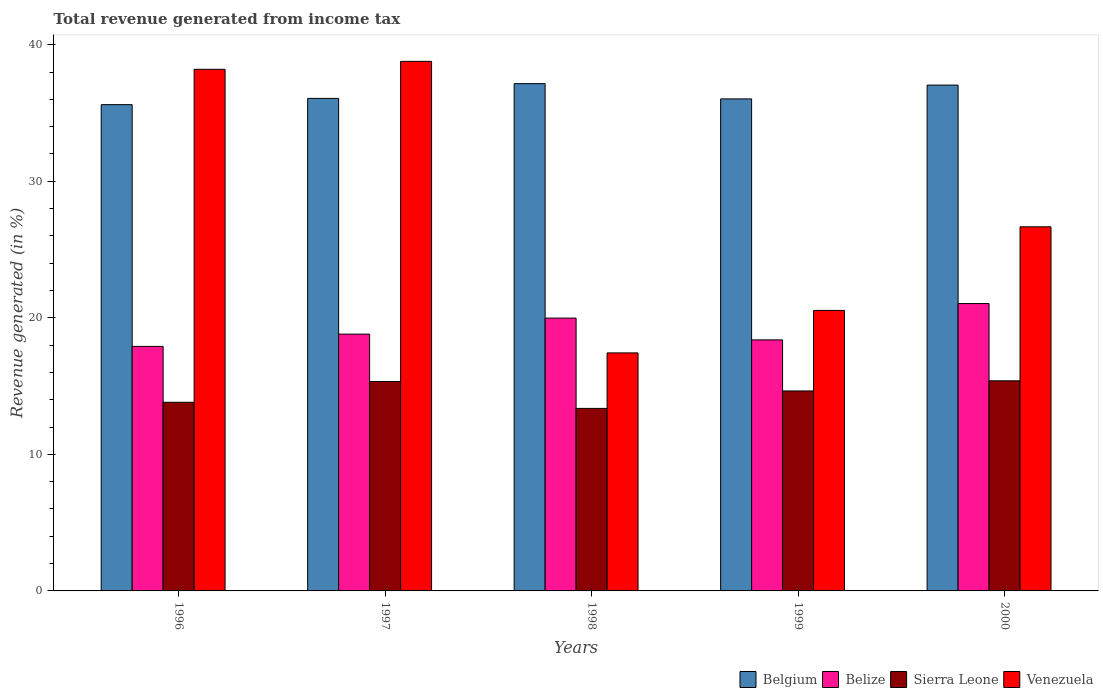Are the number of bars per tick equal to the number of legend labels?
Your response must be concise. Yes. Are the number of bars on each tick of the X-axis equal?
Provide a succinct answer. Yes. How many bars are there on the 2nd tick from the left?
Keep it short and to the point. 4. How many bars are there on the 4th tick from the right?
Offer a very short reply. 4. In how many cases, is the number of bars for a given year not equal to the number of legend labels?
Make the answer very short. 0. What is the total revenue generated in Venezuela in 1996?
Provide a succinct answer. 38.2. Across all years, what is the maximum total revenue generated in Belgium?
Offer a very short reply. 37.15. Across all years, what is the minimum total revenue generated in Sierra Leone?
Provide a succinct answer. 13.37. In which year was the total revenue generated in Belize maximum?
Provide a short and direct response. 2000. In which year was the total revenue generated in Belgium minimum?
Keep it short and to the point. 1996. What is the total total revenue generated in Venezuela in the graph?
Offer a very short reply. 141.62. What is the difference between the total revenue generated in Sierra Leone in 1997 and that in 1999?
Provide a short and direct response. 0.69. What is the difference between the total revenue generated in Belgium in 1999 and the total revenue generated in Sierra Leone in 1996?
Make the answer very short. 22.22. What is the average total revenue generated in Belize per year?
Offer a terse response. 19.22. In the year 1996, what is the difference between the total revenue generated in Belgium and total revenue generated in Sierra Leone?
Keep it short and to the point. 21.8. In how many years, is the total revenue generated in Belize greater than 12 %?
Offer a terse response. 5. What is the ratio of the total revenue generated in Venezuela in 1997 to that in 1999?
Your response must be concise. 1.89. What is the difference between the highest and the second highest total revenue generated in Venezuela?
Your answer should be compact. 0.58. What is the difference between the highest and the lowest total revenue generated in Sierra Leone?
Offer a terse response. 2.02. Is the sum of the total revenue generated in Venezuela in 1997 and 2000 greater than the maximum total revenue generated in Belize across all years?
Your answer should be compact. Yes. What does the 3rd bar from the left in 1997 represents?
Keep it short and to the point. Sierra Leone. What does the 4th bar from the right in 1996 represents?
Provide a short and direct response. Belgium. Are all the bars in the graph horizontal?
Provide a short and direct response. No. How many years are there in the graph?
Offer a terse response. 5. What is the difference between two consecutive major ticks on the Y-axis?
Keep it short and to the point. 10. Are the values on the major ticks of Y-axis written in scientific E-notation?
Offer a very short reply. No. Does the graph contain grids?
Provide a succinct answer. No. How many legend labels are there?
Offer a very short reply. 4. How are the legend labels stacked?
Provide a short and direct response. Horizontal. What is the title of the graph?
Make the answer very short. Total revenue generated from income tax. Does "Turks and Caicos Islands" appear as one of the legend labels in the graph?
Give a very brief answer. No. What is the label or title of the X-axis?
Offer a terse response. Years. What is the label or title of the Y-axis?
Ensure brevity in your answer.  Revenue generated (in %). What is the Revenue generated (in %) in Belgium in 1996?
Your answer should be compact. 35.61. What is the Revenue generated (in %) in Belize in 1996?
Give a very brief answer. 17.91. What is the Revenue generated (in %) in Sierra Leone in 1996?
Offer a very short reply. 13.81. What is the Revenue generated (in %) of Venezuela in 1996?
Your response must be concise. 38.2. What is the Revenue generated (in %) in Belgium in 1997?
Ensure brevity in your answer.  36.07. What is the Revenue generated (in %) in Belize in 1997?
Ensure brevity in your answer.  18.81. What is the Revenue generated (in %) in Sierra Leone in 1997?
Make the answer very short. 15.34. What is the Revenue generated (in %) of Venezuela in 1997?
Offer a very short reply. 38.78. What is the Revenue generated (in %) in Belgium in 1998?
Give a very brief answer. 37.15. What is the Revenue generated (in %) of Belize in 1998?
Give a very brief answer. 19.98. What is the Revenue generated (in %) in Sierra Leone in 1998?
Your answer should be very brief. 13.37. What is the Revenue generated (in %) in Venezuela in 1998?
Your response must be concise. 17.43. What is the Revenue generated (in %) of Belgium in 1999?
Provide a short and direct response. 36.03. What is the Revenue generated (in %) of Belize in 1999?
Offer a very short reply. 18.38. What is the Revenue generated (in %) of Sierra Leone in 1999?
Keep it short and to the point. 14.65. What is the Revenue generated (in %) of Venezuela in 1999?
Ensure brevity in your answer.  20.54. What is the Revenue generated (in %) in Belgium in 2000?
Offer a terse response. 37.05. What is the Revenue generated (in %) in Belize in 2000?
Provide a short and direct response. 21.05. What is the Revenue generated (in %) in Sierra Leone in 2000?
Offer a terse response. 15.39. What is the Revenue generated (in %) in Venezuela in 2000?
Your response must be concise. 26.67. Across all years, what is the maximum Revenue generated (in %) of Belgium?
Give a very brief answer. 37.15. Across all years, what is the maximum Revenue generated (in %) in Belize?
Your answer should be compact. 21.05. Across all years, what is the maximum Revenue generated (in %) of Sierra Leone?
Ensure brevity in your answer.  15.39. Across all years, what is the maximum Revenue generated (in %) in Venezuela?
Give a very brief answer. 38.78. Across all years, what is the minimum Revenue generated (in %) of Belgium?
Keep it short and to the point. 35.61. Across all years, what is the minimum Revenue generated (in %) in Belize?
Your response must be concise. 17.91. Across all years, what is the minimum Revenue generated (in %) of Sierra Leone?
Your answer should be very brief. 13.37. Across all years, what is the minimum Revenue generated (in %) in Venezuela?
Keep it short and to the point. 17.43. What is the total Revenue generated (in %) of Belgium in the graph?
Keep it short and to the point. 181.91. What is the total Revenue generated (in %) of Belize in the graph?
Give a very brief answer. 96.12. What is the total Revenue generated (in %) in Sierra Leone in the graph?
Keep it short and to the point. 72.55. What is the total Revenue generated (in %) of Venezuela in the graph?
Provide a succinct answer. 141.62. What is the difference between the Revenue generated (in %) in Belgium in 1996 and that in 1997?
Offer a very short reply. -0.46. What is the difference between the Revenue generated (in %) of Belize in 1996 and that in 1997?
Offer a terse response. -0.9. What is the difference between the Revenue generated (in %) of Sierra Leone in 1996 and that in 1997?
Your response must be concise. -1.52. What is the difference between the Revenue generated (in %) in Venezuela in 1996 and that in 1997?
Your answer should be very brief. -0.58. What is the difference between the Revenue generated (in %) of Belgium in 1996 and that in 1998?
Keep it short and to the point. -1.54. What is the difference between the Revenue generated (in %) of Belize in 1996 and that in 1998?
Make the answer very short. -2.07. What is the difference between the Revenue generated (in %) of Sierra Leone in 1996 and that in 1998?
Provide a short and direct response. 0.45. What is the difference between the Revenue generated (in %) of Venezuela in 1996 and that in 1998?
Ensure brevity in your answer.  20.77. What is the difference between the Revenue generated (in %) in Belgium in 1996 and that in 1999?
Make the answer very short. -0.42. What is the difference between the Revenue generated (in %) of Belize in 1996 and that in 1999?
Provide a succinct answer. -0.48. What is the difference between the Revenue generated (in %) in Sierra Leone in 1996 and that in 1999?
Provide a succinct answer. -0.83. What is the difference between the Revenue generated (in %) of Venezuela in 1996 and that in 1999?
Offer a very short reply. 17.66. What is the difference between the Revenue generated (in %) of Belgium in 1996 and that in 2000?
Make the answer very short. -1.43. What is the difference between the Revenue generated (in %) of Belize in 1996 and that in 2000?
Give a very brief answer. -3.14. What is the difference between the Revenue generated (in %) in Sierra Leone in 1996 and that in 2000?
Ensure brevity in your answer.  -1.57. What is the difference between the Revenue generated (in %) of Venezuela in 1996 and that in 2000?
Offer a terse response. 11.53. What is the difference between the Revenue generated (in %) in Belgium in 1997 and that in 1998?
Your answer should be compact. -1.08. What is the difference between the Revenue generated (in %) in Belize in 1997 and that in 1998?
Provide a short and direct response. -1.17. What is the difference between the Revenue generated (in %) in Sierra Leone in 1997 and that in 1998?
Ensure brevity in your answer.  1.97. What is the difference between the Revenue generated (in %) of Venezuela in 1997 and that in 1998?
Provide a succinct answer. 21.35. What is the difference between the Revenue generated (in %) of Belgium in 1997 and that in 1999?
Keep it short and to the point. 0.04. What is the difference between the Revenue generated (in %) in Belize in 1997 and that in 1999?
Ensure brevity in your answer.  0.42. What is the difference between the Revenue generated (in %) in Sierra Leone in 1997 and that in 1999?
Provide a succinct answer. 0.69. What is the difference between the Revenue generated (in %) in Venezuela in 1997 and that in 1999?
Offer a very short reply. 18.24. What is the difference between the Revenue generated (in %) of Belgium in 1997 and that in 2000?
Give a very brief answer. -0.98. What is the difference between the Revenue generated (in %) of Belize in 1997 and that in 2000?
Provide a short and direct response. -2.24. What is the difference between the Revenue generated (in %) in Sierra Leone in 1997 and that in 2000?
Make the answer very short. -0.05. What is the difference between the Revenue generated (in %) in Venezuela in 1997 and that in 2000?
Your answer should be very brief. 12.12. What is the difference between the Revenue generated (in %) in Belgium in 1998 and that in 1999?
Give a very brief answer. 1.12. What is the difference between the Revenue generated (in %) in Belize in 1998 and that in 1999?
Your response must be concise. 1.6. What is the difference between the Revenue generated (in %) in Sierra Leone in 1998 and that in 1999?
Your response must be concise. -1.28. What is the difference between the Revenue generated (in %) in Venezuela in 1998 and that in 1999?
Offer a very short reply. -3.11. What is the difference between the Revenue generated (in %) of Belgium in 1998 and that in 2000?
Ensure brevity in your answer.  0.1. What is the difference between the Revenue generated (in %) of Belize in 1998 and that in 2000?
Ensure brevity in your answer.  -1.07. What is the difference between the Revenue generated (in %) in Sierra Leone in 1998 and that in 2000?
Provide a succinct answer. -2.02. What is the difference between the Revenue generated (in %) of Venezuela in 1998 and that in 2000?
Keep it short and to the point. -9.24. What is the difference between the Revenue generated (in %) of Belgium in 1999 and that in 2000?
Keep it short and to the point. -1.01. What is the difference between the Revenue generated (in %) in Belize in 1999 and that in 2000?
Your answer should be very brief. -2.66. What is the difference between the Revenue generated (in %) of Sierra Leone in 1999 and that in 2000?
Ensure brevity in your answer.  -0.74. What is the difference between the Revenue generated (in %) of Venezuela in 1999 and that in 2000?
Your response must be concise. -6.12. What is the difference between the Revenue generated (in %) in Belgium in 1996 and the Revenue generated (in %) in Belize in 1997?
Offer a terse response. 16.81. What is the difference between the Revenue generated (in %) of Belgium in 1996 and the Revenue generated (in %) of Sierra Leone in 1997?
Your response must be concise. 20.28. What is the difference between the Revenue generated (in %) of Belgium in 1996 and the Revenue generated (in %) of Venezuela in 1997?
Offer a very short reply. -3.17. What is the difference between the Revenue generated (in %) in Belize in 1996 and the Revenue generated (in %) in Sierra Leone in 1997?
Offer a very short reply. 2.57. What is the difference between the Revenue generated (in %) in Belize in 1996 and the Revenue generated (in %) in Venezuela in 1997?
Your answer should be compact. -20.88. What is the difference between the Revenue generated (in %) of Sierra Leone in 1996 and the Revenue generated (in %) of Venezuela in 1997?
Provide a short and direct response. -24.97. What is the difference between the Revenue generated (in %) in Belgium in 1996 and the Revenue generated (in %) in Belize in 1998?
Your answer should be compact. 15.63. What is the difference between the Revenue generated (in %) in Belgium in 1996 and the Revenue generated (in %) in Sierra Leone in 1998?
Give a very brief answer. 22.25. What is the difference between the Revenue generated (in %) in Belgium in 1996 and the Revenue generated (in %) in Venezuela in 1998?
Give a very brief answer. 18.18. What is the difference between the Revenue generated (in %) of Belize in 1996 and the Revenue generated (in %) of Sierra Leone in 1998?
Ensure brevity in your answer.  4.54. What is the difference between the Revenue generated (in %) of Belize in 1996 and the Revenue generated (in %) of Venezuela in 1998?
Offer a terse response. 0.48. What is the difference between the Revenue generated (in %) of Sierra Leone in 1996 and the Revenue generated (in %) of Venezuela in 1998?
Your answer should be very brief. -3.62. What is the difference between the Revenue generated (in %) in Belgium in 1996 and the Revenue generated (in %) in Belize in 1999?
Your answer should be very brief. 17.23. What is the difference between the Revenue generated (in %) in Belgium in 1996 and the Revenue generated (in %) in Sierra Leone in 1999?
Your answer should be very brief. 20.97. What is the difference between the Revenue generated (in %) of Belgium in 1996 and the Revenue generated (in %) of Venezuela in 1999?
Your answer should be very brief. 15.07. What is the difference between the Revenue generated (in %) of Belize in 1996 and the Revenue generated (in %) of Sierra Leone in 1999?
Provide a short and direct response. 3.26. What is the difference between the Revenue generated (in %) in Belize in 1996 and the Revenue generated (in %) in Venezuela in 1999?
Your response must be concise. -2.63. What is the difference between the Revenue generated (in %) of Sierra Leone in 1996 and the Revenue generated (in %) of Venezuela in 1999?
Provide a succinct answer. -6.73. What is the difference between the Revenue generated (in %) in Belgium in 1996 and the Revenue generated (in %) in Belize in 2000?
Give a very brief answer. 14.57. What is the difference between the Revenue generated (in %) in Belgium in 1996 and the Revenue generated (in %) in Sierra Leone in 2000?
Your answer should be compact. 20.23. What is the difference between the Revenue generated (in %) in Belgium in 1996 and the Revenue generated (in %) in Venezuela in 2000?
Your response must be concise. 8.95. What is the difference between the Revenue generated (in %) in Belize in 1996 and the Revenue generated (in %) in Sierra Leone in 2000?
Your answer should be very brief. 2.52. What is the difference between the Revenue generated (in %) in Belize in 1996 and the Revenue generated (in %) in Venezuela in 2000?
Provide a short and direct response. -8.76. What is the difference between the Revenue generated (in %) of Sierra Leone in 1996 and the Revenue generated (in %) of Venezuela in 2000?
Your response must be concise. -12.85. What is the difference between the Revenue generated (in %) of Belgium in 1997 and the Revenue generated (in %) of Belize in 1998?
Give a very brief answer. 16.09. What is the difference between the Revenue generated (in %) of Belgium in 1997 and the Revenue generated (in %) of Sierra Leone in 1998?
Offer a terse response. 22.7. What is the difference between the Revenue generated (in %) of Belgium in 1997 and the Revenue generated (in %) of Venezuela in 1998?
Offer a very short reply. 18.64. What is the difference between the Revenue generated (in %) in Belize in 1997 and the Revenue generated (in %) in Sierra Leone in 1998?
Ensure brevity in your answer.  5.44. What is the difference between the Revenue generated (in %) in Belize in 1997 and the Revenue generated (in %) in Venezuela in 1998?
Offer a very short reply. 1.38. What is the difference between the Revenue generated (in %) of Sierra Leone in 1997 and the Revenue generated (in %) of Venezuela in 1998?
Provide a succinct answer. -2.1. What is the difference between the Revenue generated (in %) of Belgium in 1997 and the Revenue generated (in %) of Belize in 1999?
Your answer should be compact. 17.68. What is the difference between the Revenue generated (in %) of Belgium in 1997 and the Revenue generated (in %) of Sierra Leone in 1999?
Your response must be concise. 21.42. What is the difference between the Revenue generated (in %) of Belgium in 1997 and the Revenue generated (in %) of Venezuela in 1999?
Your response must be concise. 15.53. What is the difference between the Revenue generated (in %) in Belize in 1997 and the Revenue generated (in %) in Sierra Leone in 1999?
Your answer should be compact. 4.16. What is the difference between the Revenue generated (in %) of Belize in 1997 and the Revenue generated (in %) of Venezuela in 1999?
Make the answer very short. -1.74. What is the difference between the Revenue generated (in %) in Sierra Leone in 1997 and the Revenue generated (in %) in Venezuela in 1999?
Make the answer very short. -5.21. What is the difference between the Revenue generated (in %) in Belgium in 1997 and the Revenue generated (in %) in Belize in 2000?
Provide a short and direct response. 15.02. What is the difference between the Revenue generated (in %) of Belgium in 1997 and the Revenue generated (in %) of Sierra Leone in 2000?
Ensure brevity in your answer.  20.68. What is the difference between the Revenue generated (in %) of Belgium in 1997 and the Revenue generated (in %) of Venezuela in 2000?
Provide a short and direct response. 9.4. What is the difference between the Revenue generated (in %) of Belize in 1997 and the Revenue generated (in %) of Sierra Leone in 2000?
Offer a terse response. 3.42. What is the difference between the Revenue generated (in %) of Belize in 1997 and the Revenue generated (in %) of Venezuela in 2000?
Your answer should be very brief. -7.86. What is the difference between the Revenue generated (in %) of Sierra Leone in 1997 and the Revenue generated (in %) of Venezuela in 2000?
Your answer should be compact. -11.33. What is the difference between the Revenue generated (in %) of Belgium in 1998 and the Revenue generated (in %) of Belize in 1999?
Ensure brevity in your answer.  18.76. What is the difference between the Revenue generated (in %) of Belgium in 1998 and the Revenue generated (in %) of Sierra Leone in 1999?
Ensure brevity in your answer.  22.5. What is the difference between the Revenue generated (in %) in Belgium in 1998 and the Revenue generated (in %) in Venezuela in 1999?
Offer a terse response. 16.61. What is the difference between the Revenue generated (in %) in Belize in 1998 and the Revenue generated (in %) in Sierra Leone in 1999?
Your answer should be compact. 5.33. What is the difference between the Revenue generated (in %) in Belize in 1998 and the Revenue generated (in %) in Venezuela in 1999?
Keep it short and to the point. -0.56. What is the difference between the Revenue generated (in %) of Sierra Leone in 1998 and the Revenue generated (in %) of Venezuela in 1999?
Give a very brief answer. -7.17. What is the difference between the Revenue generated (in %) in Belgium in 1998 and the Revenue generated (in %) in Belize in 2000?
Offer a very short reply. 16.1. What is the difference between the Revenue generated (in %) of Belgium in 1998 and the Revenue generated (in %) of Sierra Leone in 2000?
Provide a succinct answer. 21.76. What is the difference between the Revenue generated (in %) of Belgium in 1998 and the Revenue generated (in %) of Venezuela in 2000?
Your response must be concise. 10.48. What is the difference between the Revenue generated (in %) of Belize in 1998 and the Revenue generated (in %) of Sierra Leone in 2000?
Ensure brevity in your answer.  4.59. What is the difference between the Revenue generated (in %) of Belize in 1998 and the Revenue generated (in %) of Venezuela in 2000?
Your answer should be very brief. -6.69. What is the difference between the Revenue generated (in %) of Sierra Leone in 1998 and the Revenue generated (in %) of Venezuela in 2000?
Provide a short and direct response. -13.3. What is the difference between the Revenue generated (in %) of Belgium in 1999 and the Revenue generated (in %) of Belize in 2000?
Your answer should be very brief. 14.99. What is the difference between the Revenue generated (in %) of Belgium in 1999 and the Revenue generated (in %) of Sierra Leone in 2000?
Offer a terse response. 20.65. What is the difference between the Revenue generated (in %) in Belgium in 1999 and the Revenue generated (in %) in Venezuela in 2000?
Give a very brief answer. 9.37. What is the difference between the Revenue generated (in %) of Belize in 1999 and the Revenue generated (in %) of Sierra Leone in 2000?
Your answer should be very brief. 3. What is the difference between the Revenue generated (in %) in Belize in 1999 and the Revenue generated (in %) in Venezuela in 2000?
Provide a short and direct response. -8.28. What is the difference between the Revenue generated (in %) of Sierra Leone in 1999 and the Revenue generated (in %) of Venezuela in 2000?
Offer a terse response. -12.02. What is the average Revenue generated (in %) of Belgium per year?
Your answer should be very brief. 36.38. What is the average Revenue generated (in %) of Belize per year?
Ensure brevity in your answer.  19.22. What is the average Revenue generated (in %) in Sierra Leone per year?
Ensure brevity in your answer.  14.51. What is the average Revenue generated (in %) in Venezuela per year?
Offer a terse response. 28.32. In the year 1996, what is the difference between the Revenue generated (in %) of Belgium and Revenue generated (in %) of Belize?
Give a very brief answer. 17.7. In the year 1996, what is the difference between the Revenue generated (in %) of Belgium and Revenue generated (in %) of Sierra Leone?
Your answer should be compact. 21.8. In the year 1996, what is the difference between the Revenue generated (in %) in Belgium and Revenue generated (in %) in Venezuela?
Give a very brief answer. -2.59. In the year 1996, what is the difference between the Revenue generated (in %) in Belize and Revenue generated (in %) in Sierra Leone?
Provide a succinct answer. 4.09. In the year 1996, what is the difference between the Revenue generated (in %) in Belize and Revenue generated (in %) in Venezuela?
Your answer should be compact. -20.29. In the year 1996, what is the difference between the Revenue generated (in %) of Sierra Leone and Revenue generated (in %) of Venezuela?
Your answer should be compact. -24.39. In the year 1997, what is the difference between the Revenue generated (in %) in Belgium and Revenue generated (in %) in Belize?
Offer a very short reply. 17.26. In the year 1997, what is the difference between the Revenue generated (in %) in Belgium and Revenue generated (in %) in Sierra Leone?
Give a very brief answer. 20.73. In the year 1997, what is the difference between the Revenue generated (in %) of Belgium and Revenue generated (in %) of Venezuela?
Keep it short and to the point. -2.71. In the year 1997, what is the difference between the Revenue generated (in %) in Belize and Revenue generated (in %) in Sierra Leone?
Provide a short and direct response. 3.47. In the year 1997, what is the difference between the Revenue generated (in %) in Belize and Revenue generated (in %) in Venezuela?
Give a very brief answer. -19.98. In the year 1997, what is the difference between the Revenue generated (in %) in Sierra Leone and Revenue generated (in %) in Venezuela?
Ensure brevity in your answer.  -23.45. In the year 1998, what is the difference between the Revenue generated (in %) in Belgium and Revenue generated (in %) in Belize?
Your answer should be compact. 17.17. In the year 1998, what is the difference between the Revenue generated (in %) in Belgium and Revenue generated (in %) in Sierra Leone?
Your answer should be compact. 23.78. In the year 1998, what is the difference between the Revenue generated (in %) of Belgium and Revenue generated (in %) of Venezuela?
Provide a succinct answer. 19.72. In the year 1998, what is the difference between the Revenue generated (in %) in Belize and Revenue generated (in %) in Sierra Leone?
Your answer should be very brief. 6.61. In the year 1998, what is the difference between the Revenue generated (in %) of Belize and Revenue generated (in %) of Venezuela?
Your answer should be compact. 2.55. In the year 1998, what is the difference between the Revenue generated (in %) of Sierra Leone and Revenue generated (in %) of Venezuela?
Keep it short and to the point. -4.06. In the year 1999, what is the difference between the Revenue generated (in %) in Belgium and Revenue generated (in %) in Belize?
Keep it short and to the point. 17.65. In the year 1999, what is the difference between the Revenue generated (in %) in Belgium and Revenue generated (in %) in Sierra Leone?
Make the answer very short. 21.39. In the year 1999, what is the difference between the Revenue generated (in %) of Belgium and Revenue generated (in %) of Venezuela?
Ensure brevity in your answer.  15.49. In the year 1999, what is the difference between the Revenue generated (in %) of Belize and Revenue generated (in %) of Sierra Leone?
Provide a short and direct response. 3.74. In the year 1999, what is the difference between the Revenue generated (in %) in Belize and Revenue generated (in %) in Venezuela?
Ensure brevity in your answer.  -2.16. In the year 1999, what is the difference between the Revenue generated (in %) in Sierra Leone and Revenue generated (in %) in Venezuela?
Make the answer very short. -5.9. In the year 2000, what is the difference between the Revenue generated (in %) in Belgium and Revenue generated (in %) in Belize?
Offer a terse response. 16. In the year 2000, what is the difference between the Revenue generated (in %) of Belgium and Revenue generated (in %) of Sierra Leone?
Give a very brief answer. 21.66. In the year 2000, what is the difference between the Revenue generated (in %) of Belgium and Revenue generated (in %) of Venezuela?
Give a very brief answer. 10.38. In the year 2000, what is the difference between the Revenue generated (in %) of Belize and Revenue generated (in %) of Sierra Leone?
Offer a terse response. 5.66. In the year 2000, what is the difference between the Revenue generated (in %) of Belize and Revenue generated (in %) of Venezuela?
Offer a very short reply. -5.62. In the year 2000, what is the difference between the Revenue generated (in %) of Sierra Leone and Revenue generated (in %) of Venezuela?
Offer a terse response. -11.28. What is the ratio of the Revenue generated (in %) in Belgium in 1996 to that in 1997?
Make the answer very short. 0.99. What is the ratio of the Revenue generated (in %) of Belize in 1996 to that in 1997?
Your answer should be very brief. 0.95. What is the ratio of the Revenue generated (in %) in Sierra Leone in 1996 to that in 1997?
Give a very brief answer. 0.9. What is the ratio of the Revenue generated (in %) in Belgium in 1996 to that in 1998?
Ensure brevity in your answer.  0.96. What is the ratio of the Revenue generated (in %) of Belize in 1996 to that in 1998?
Offer a terse response. 0.9. What is the ratio of the Revenue generated (in %) of Sierra Leone in 1996 to that in 1998?
Provide a succinct answer. 1.03. What is the ratio of the Revenue generated (in %) in Venezuela in 1996 to that in 1998?
Keep it short and to the point. 2.19. What is the ratio of the Revenue generated (in %) of Belgium in 1996 to that in 1999?
Your answer should be very brief. 0.99. What is the ratio of the Revenue generated (in %) of Belize in 1996 to that in 1999?
Your answer should be very brief. 0.97. What is the ratio of the Revenue generated (in %) in Sierra Leone in 1996 to that in 1999?
Your answer should be very brief. 0.94. What is the ratio of the Revenue generated (in %) of Venezuela in 1996 to that in 1999?
Your response must be concise. 1.86. What is the ratio of the Revenue generated (in %) of Belgium in 1996 to that in 2000?
Give a very brief answer. 0.96. What is the ratio of the Revenue generated (in %) in Belize in 1996 to that in 2000?
Your response must be concise. 0.85. What is the ratio of the Revenue generated (in %) in Sierra Leone in 1996 to that in 2000?
Make the answer very short. 0.9. What is the ratio of the Revenue generated (in %) of Venezuela in 1996 to that in 2000?
Ensure brevity in your answer.  1.43. What is the ratio of the Revenue generated (in %) in Belgium in 1997 to that in 1998?
Your response must be concise. 0.97. What is the ratio of the Revenue generated (in %) in Belize in 1997 to that in 1998?
Offer a terse response. 0.94. What is the ratio of the Revenue generated (in %) in Sierra Leone in 1997 to that in 1998?
Make the answer very short. 1.15. What is the ratio of the Revenue generated (in %) in Venezuela in 1997 to that in 1998?
Keep it short and to the point. 2.22. What is the ratio of the Revenue generated (in %) of Sierra Leone in 1997 to that in 1999?
Provide a short and direct response. 1.05. What is the ratio of the Revenue generated (in %) of Venezuela in 1997 to that in 1999?
Your answer should be very brief. 1.89. What is the ratio of the Revenue generated (in %) in Belgium in 1997 to that in 2000?
Give a very brief answer. 0.97. What is the ratio of the Revenue generated (in %) in Belize in 1997 to that in 2000?
Your response must be concise. 0.89. What is the ratio of the Revenue generated (in %) in Sierra Leone in 1997 to that in 2000?
Make the answer very short. 1. What is the ratio of the Revenue generated (in %) of Venezuela in 1997 to that in 2000?
Your answer should be compact. 1.45. What is the ratio of the Revenue generated (in %) of Belgium in 1998 to that in 1999?
Offer a terse response. 1.03. What is the ratio of the Revenue generated (in %) in Belize in 1998 to that in 1999?
Keep it short and to the point. 1.09. What is the ratio of the Revenue generated (in %) in Sierra Leone in 1998 to that in 1999?
Ensure brevity in your answer.  0.91. What is the ratio of the Revenue generated (in %) of Venezuela in 1998 to that in 1999?
Offer a very short reply. 0.85. What is the ratio of the Revenue generated (in %) of Belize in 1998 to that in 2000?
Offer a very short reply. 0.95. What is the ratio of the Revenue generated (in %) in Sierra Leone in 1998 to that in 2000?
Make the answer very short. 0.87. What is the ratio of the Revenue generated (in %) in Venezuela in 1998 to that in 2000?
Make the answer very short. 0.65. What is the ratio of the Revenue generated (in %) of Belgium in 1999 to that in 2000?
Make the answer very short. 0.97. What is the ratio of the Revenue generated (in %) in Belize in 1999 to that in 2000?
Your response must be concise. 0.87. What is the ratio of the Revenue generated (in %) of Sierra Leone in 1999 to that in 2000?
Keep it short and to the point. 0.95. What is the ratio of the Revenue generated (in %) in Venezuela in 1999 to that in 2000?
Offer a very short reply. 0.77. What is the difference between the highest and the second highest Revenue generated (in %) in Belgium?
Offer a terse response. 0.1. What is the difference between the highest and the second highest Revenue generated (in %) in Belize?
Give a very brief answer. 1.07. What is the difference between the highest and the second highest Revenue generated (in %) in Sierra Leone?
Offer a very short reply. 0.05. What is the difference between the highest and the second highest Revenue generated (in %) of Venezuela?
Provide a succinct answer. 0.58. What is the difference between the highest and the lowest Revenue generated (in %) of Belgium?
Your answer should be very brief. 1.54. What is the difference between the highest and the lowest Revenue generated (in %) of Belize?
Your answer should be very brief. 3.14. What is the difference between the highest and the lowest Revenue generated (in %) of Sierra Leone?
Your answer should be very brief. 2.02. What is the difference between the highest and the lowest Revenue generated (in %) in Venezuela?
Make the answer very short. 21.35. 